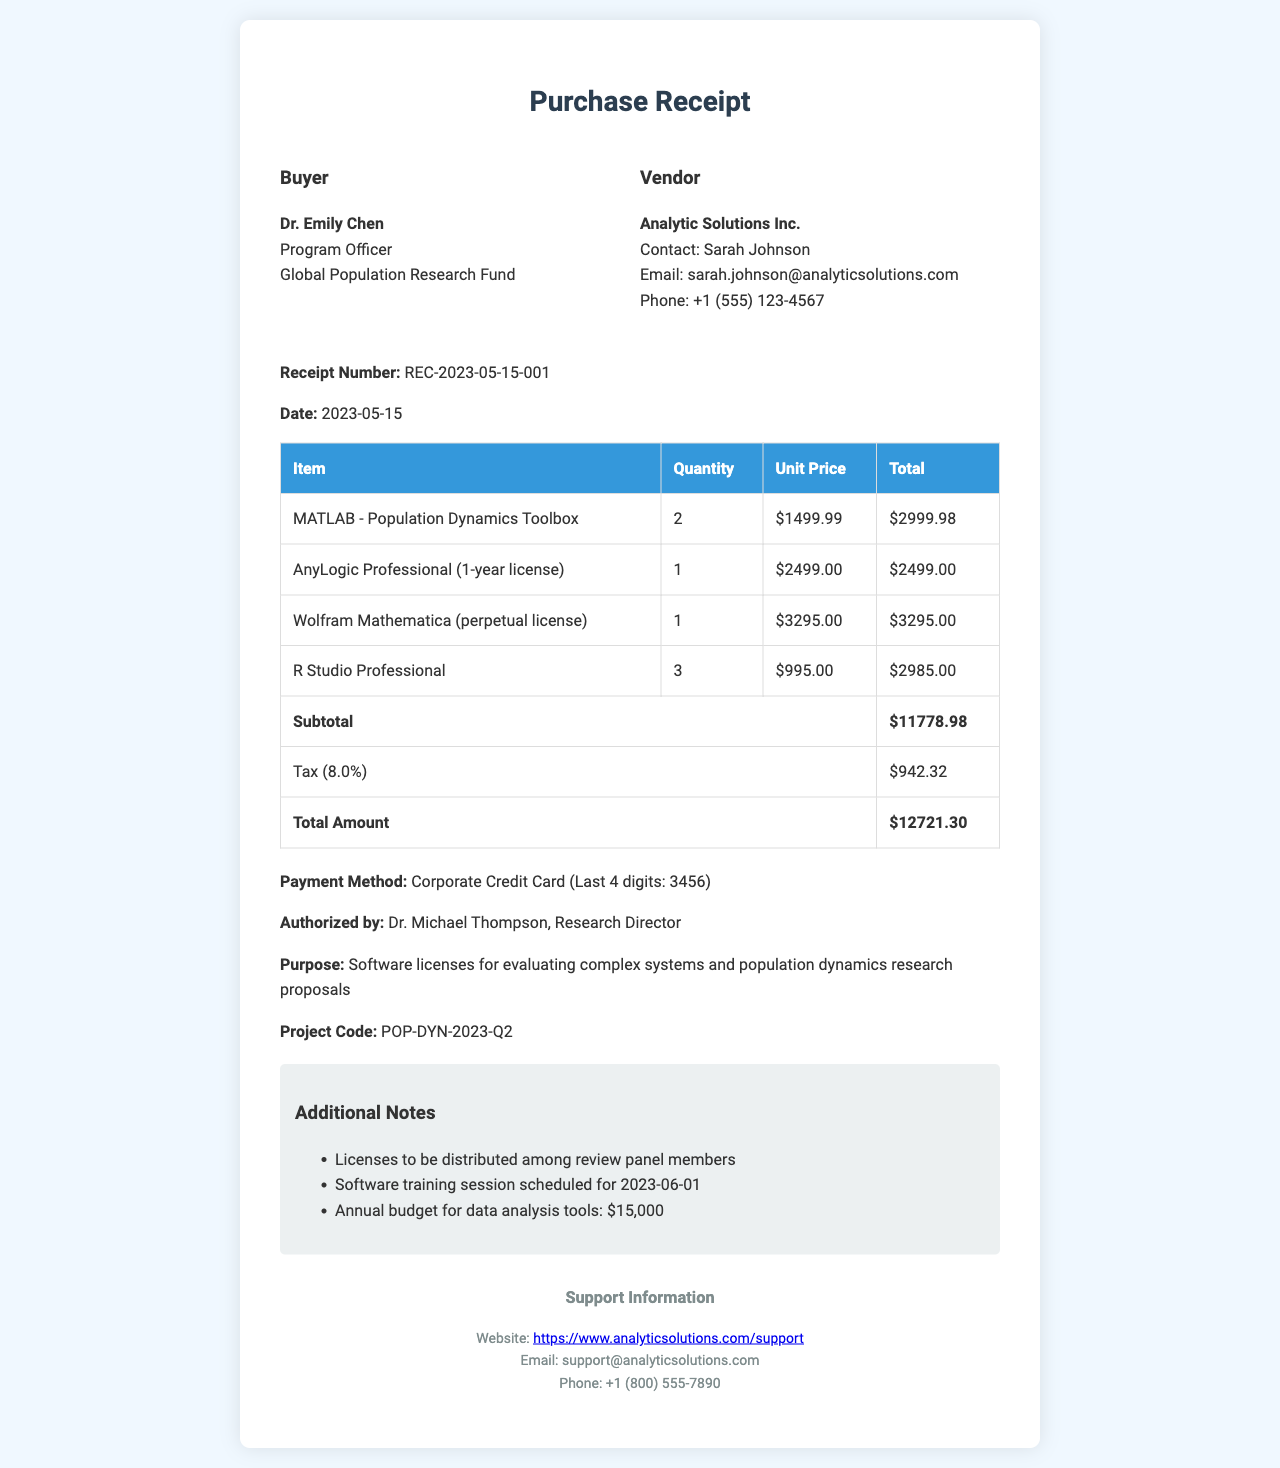What is the receipt number? The receipt number is a unique identifier for this transaction.
Answer: REC-2023-05-15-001 What is the total amount spent? The total amount is the sum of the subtotal and tax amount.
Answer: $12721.30 Who authorized the payment? The authorized person is mentioned in the receipt and is responsible for approving the payment.
Answer: Dr. Michael Thompson, Research Director How many licenses of R Studio Professional were purchased? The quantity of R Studio Professional licenses is listed in the item details.
Answer: 3 What is the tax rate applied to the purchase? The tax rate is stated in the document and is used to calculate the tax amount.
Answer: 8% What is the date of the purchase? The date indicates when the transaction took place and is included in the receipt.
Answer: 2023-05-15 What is the purpose of the purchase? The purpose explains why the software licenses were acquired and is outlined on the receipt.
Answer: Software licenses for evaluating complex systems and population dynamics research proposals What is the name of the vendor? The vendor is the company from which the software licenses were purchased and is listed at the top of the receipt.
Answer: Analytic Solutions Inc What is the project code associated with this purchase? The project code is used for tracking and categorizing the expenses related to specific projects.
Answer: POP-DYN-2023-Q2 